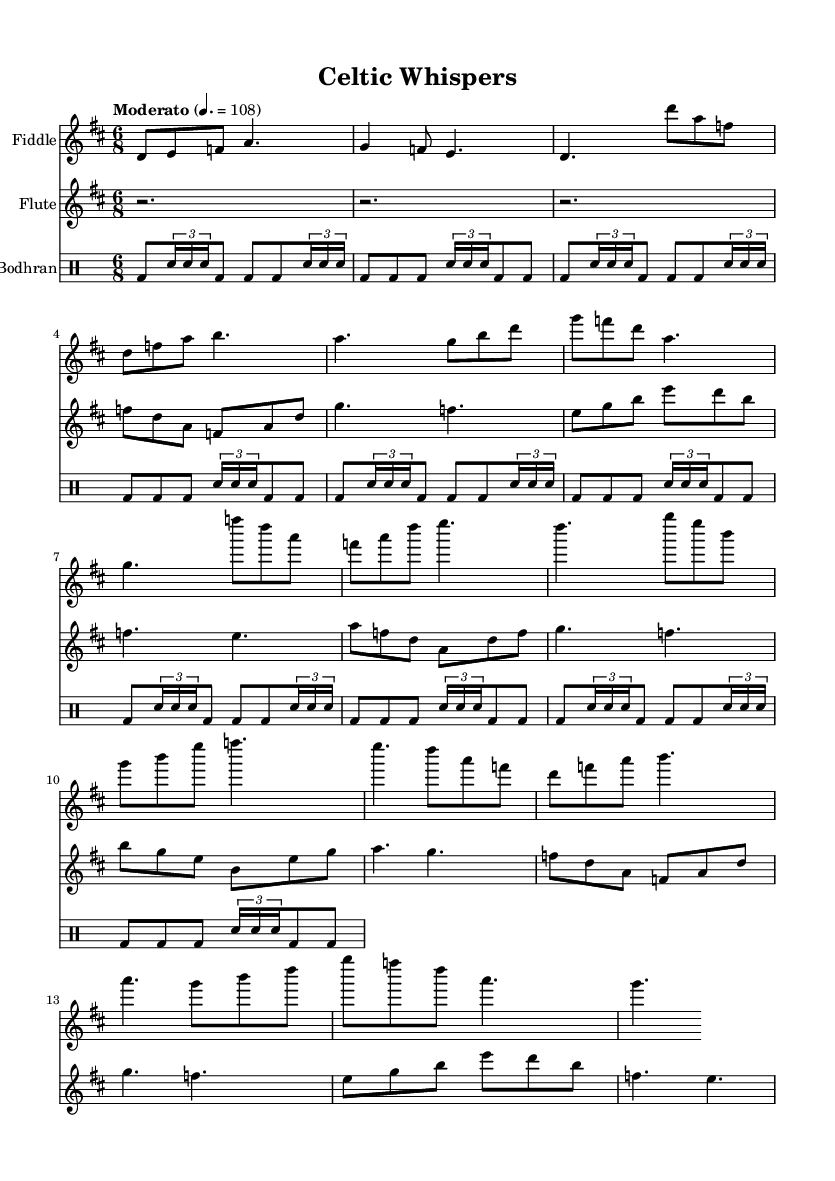What is the key signature of this music? The key signature is D major, which has two sharps (F# and C#). You can identify the key signature located at the beginning of the staff before the time signature.
Answer: D major What is the time signature of this music? The time signature is 6/8, which means there are six eighth notes per measure. This can be seen at the beginning of the score, positioned after the key signature.
Answer: 6/8 What is the tempo marking of this music? The tempo marking is "Moderato" with a specific metronome marking of quarter note = 108. This is indicated above the staff, providing guidance on the speed of the piece.
Answer: Moderato How many sections does the fiddle part have? The fiddle part has two sections labeled as A and B, with the A section repeated after the B section, as indicated in the composition.
Answer: Two What instruments are featured in this piece? The featured instruments are the fiddle, flute, and bodhran. This is illustrated by the different staffs for each instrument in the score.
Answer: Fiddle, flute, bodhran Which section contains a focus on descending melodic lines? The B section contains descending melodic lines prominently, particularly in the fiddle part, where the notes move from higher to lower pitches throughout the section.
Answer: B section What rhythmic feature is emphasized in the bodhran part? The bodhran part emphasizes a repeating sixteenth note pattern, evident in its rhythmic project throughout the piece, particularly in syncopation with the other instruments.
Answer: Syncopated rhythm 